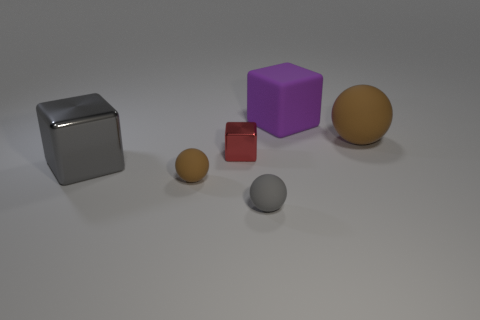Add 3 green shiny objects. How many objects exist? 9 Add 5 big brown metal cylinders. How many big brown metal cylinders exist? 5 Subtract 0 cyan balls. How many objects are left? 6 Subtract all purple things. Subtract all large things. How many objects are left? 2 Add 1 matte blocks. How many matte blocks are left? 2 